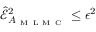<formula> <loc_0><loc_0><loc_500><loc_500>\widehat { \mathcal { E } } _ { A _ { M L M C } } ^ { 2 } \leq \epsilon ^ { 2 }</formula> 